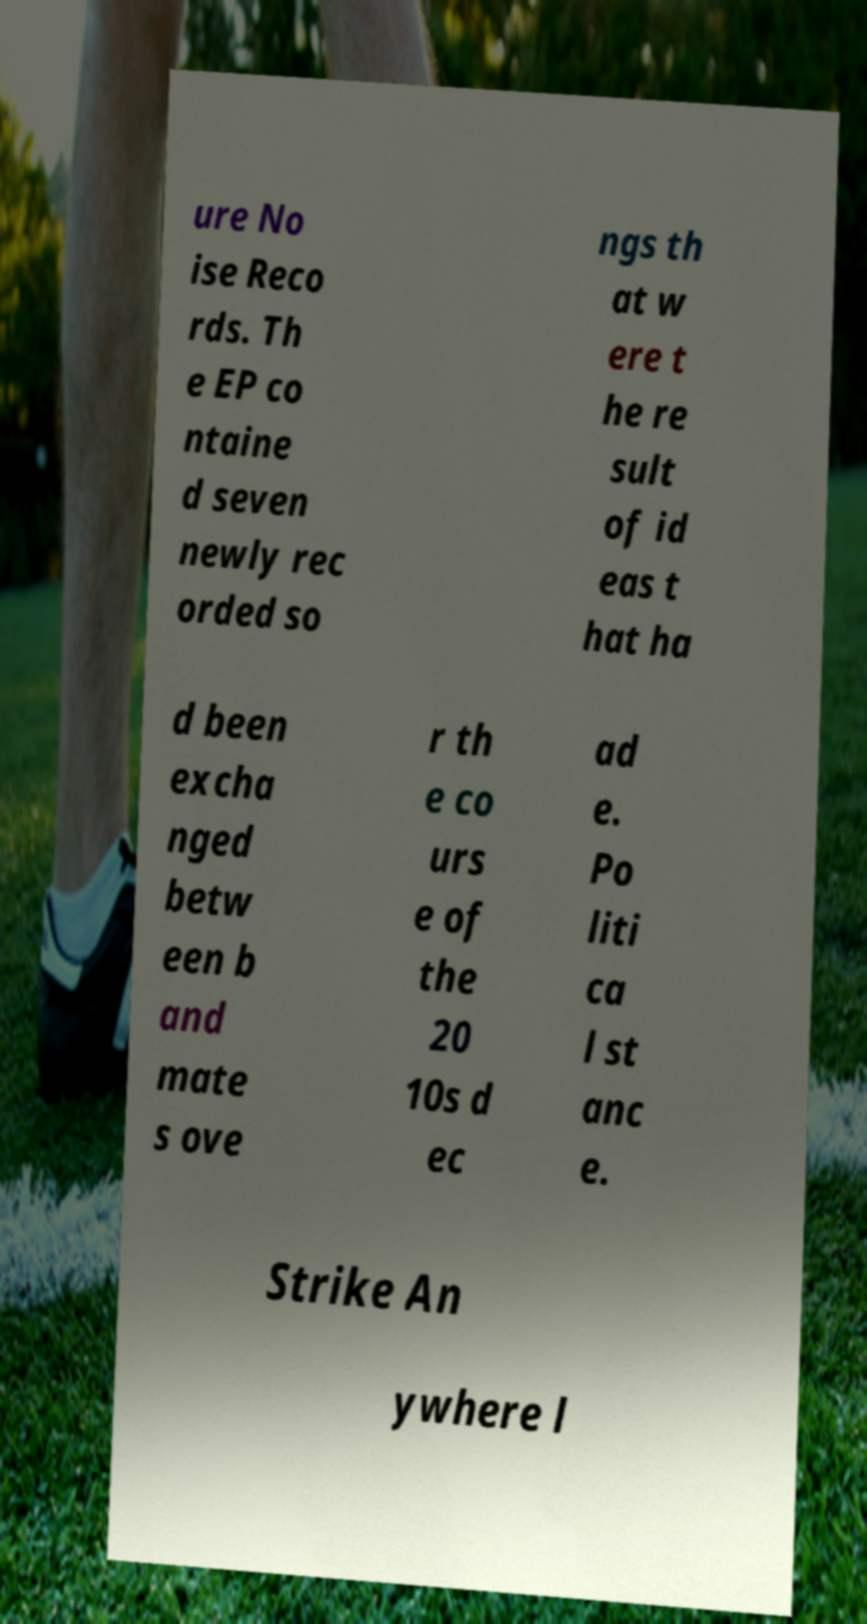For documentation purposes, I need the text within this image transcribed. Could you provide that? ure No ise Reco rds. Th e EP co ntaine d seven newly rec orded so ngs th at w ere t he re sult of id eas t hat ha d been excha nged betw een b and mate s ove r th e co urs e of the 20 10s d ec ad e. Po liti ca l st anc e. Strike An ywhere l 